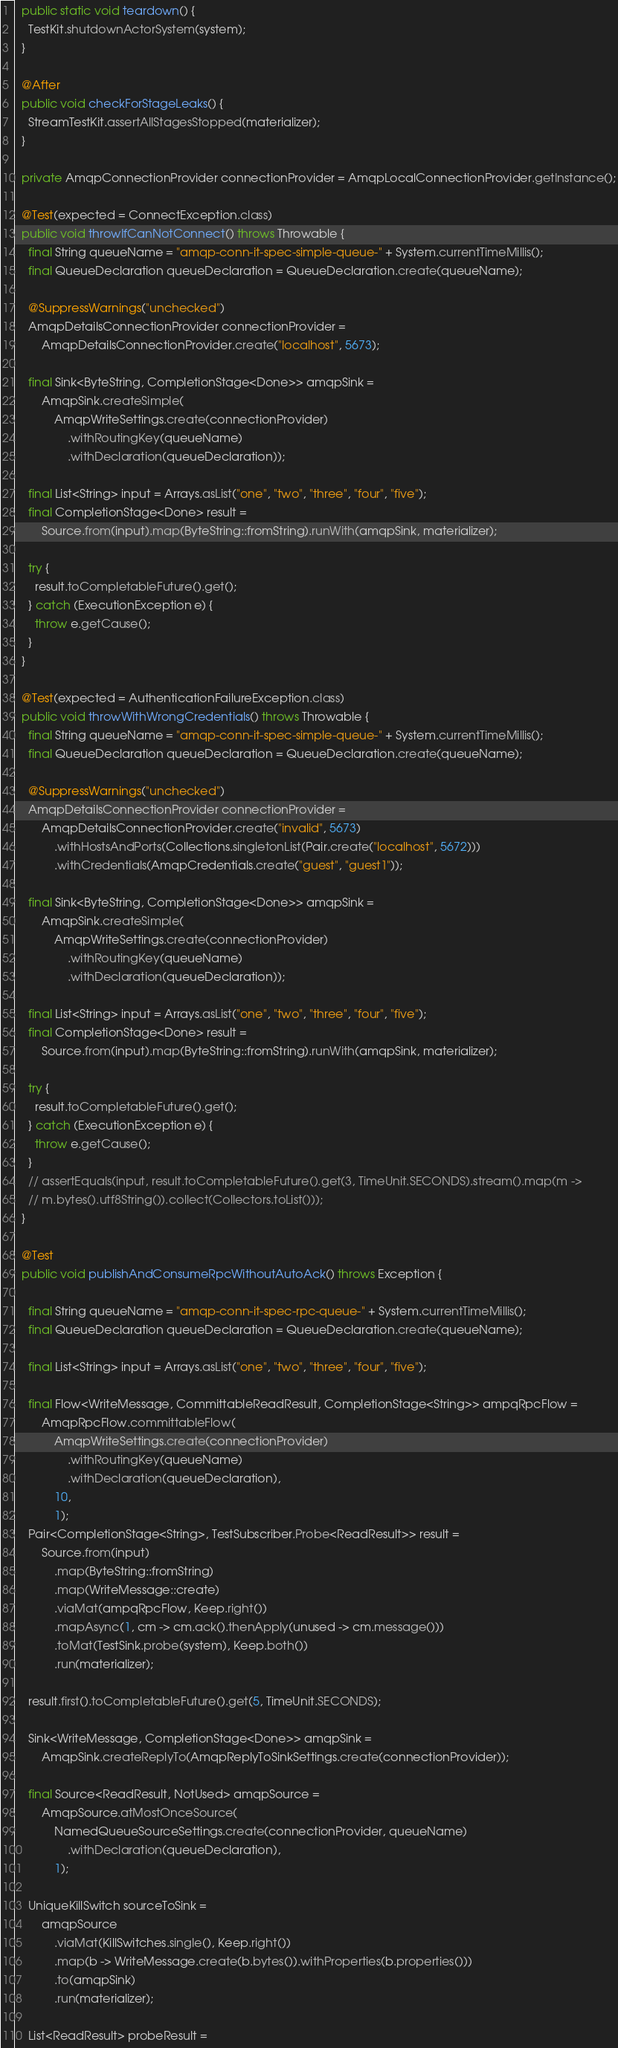Convert code to text. <code><loc_0><loc_0><loc_500><loc_500><_Java_>  public static void teardown() {
    TestKit.shutdownActorSystem(system);
  }

  @After
  public void checkForStageLeaks() {
    StreamTestKit.assertAllStagesStopped(materializer);
  }

  private AmqpConnectionProvider connectionProvider = AmqpLocalConnectionProvider.getInstance();

  @Test(expected = ConnectException.class)
  public void throwIfCanNotConnect() throws Throwable {
    final String queueName = "amqp-conn-it-spec-simple-queue-" + System.currentTimeMillis();
    final QueueDeclaration queueDeclaration = QueueDeclaration.create(queueName);

    @SuppressWarnings("unchecked")
    AmqpDetailsConnectionProvider connectionProvider =
        AmqpDetailsConnectionProvider.create("localhost", 5673);

    final Sink<ByteString, CompletionStage<Done>> amqpSink =
        AmqpSink.createSimple(
            AmqpWriteSettings.create(connectionProvider)
                .withRoutingKey(queueName)
                .withDeclaration(queueDeclaration));

    final List<String> input = Arrays.asList("one", "two", "three", "four", "five");
    final CompletionStage<Done> result =
        Source.from(input).map(ByteString::fromString).runWith(amqpSink, materializer);

    try {
      result.toCompletableFuture().get();
    } catch (ExecutionException e) {
      throw e.getCause();
    }
  }

  @Test(expected = AuthenticationFailureException.class)
  public void throwWithWrongCredentials() throws Throwable {
    final String queueName = "amqp-conn-it-spec-simple-queue-" + System.currentTimeMillis();
    final QueueDeclaration queueDeclaration = QueueDeclaration.create(queueName);

    @SuppressWarnings("unchecked")
    AmqpDetailsConnectionProvider connectionProvider =
        AmqpDetailsConnectionProvider.create("invalid", 5673)
            .withHostsAndPorts(Collections.singletonList(Pair.create("localhost", 5672)))
            .withCredentials(AmqpCredentials.create("guest", "guest1"));

    final Sink<ByteString, CompletionStage<Done>> amqpSink =
        AmqpSink.createSimple(
            AmqpWriteSettings.create(connectionProvider)
                .withRoutingKey(queueName)
                .withDeclaration(queueDeclaration));

    final List<String> input = Arrays.asList("one", "two", "three", "four", "five");
    final CompletionStage<Done> result =
        Source.from(input).map(ByteString::fromString).runWith(amqpSink, materializer);

    try {
      result.toCompletableFuture().get();
    } catch (ExecutionException e) {
      throw e.getCause();
    }
    // assertEquals(input, result.toCompletableFuture().get(3, TimeUnit.SECONDS).stream().map(m ->
    // m.bytes().utf8String()).collect(Collectors.toList()));
  }

  @Test
  public void publishAndConsumeRpcWithoutAutoAck() throws Exception {

    final String queueName = "amqp-conn-it-spec-rpc-queue-" + System.currentTimeMillis();
    final QueueDeclaration queueDeclaration = QueueDeclaration.create(queueName);

    final List<String> input = Arrays.asList("one", "two", "three", "four", "five");

    final Flow<WriteMessage, CommittableReadResult, CompletionStage<String>> ampqRpcFlow =
        AmqpRpcFlow.committableFlow(
            AmqpWriteSettings.create(connectionProvider)
                .withRoutingKey(queueName)
                .withDeclaration(queueDeclaration),
            10,
            1);
    Pair<CompletionStage<String>, TestSubscriber.Probe<ReadResult>> result =
        Source.from(input)
            .map(ByteString::fromString)
            .map(WriteMessage::create)
            .viaMat(ampqRpcFlow, Keep.right())
            .mapAsync(1, cm -> cm.ack().thenApply(unused -> cm.message()))
            .toMat(TestSink.probe(system), Keep.both())
            .run(materializer);

    result.first().toCompletableFuture().get(5, TimeUnit.SECONDS);

    Sink<WriteMessage, CompletionStage<Done>> amqpSink =
        AmqpSink.createReplyTo(AmqpReplyToSinkSettings.create(connectionProvider));

    final Source<ReadResult, NotUsed> amqpSource =
        AmqpSource.atMostOnceSource(
            NamedQueueSourceSettings.create(connectionProvider, queueName)
                .withDeclaration(queueDeclaration),
            1);

    UniqueKillSwitch sourceToSink =
        amqpSource
            .viaMat(KillSwitches.single(), Keep.right())
            .map(b -> WriteMessage.create(b.bytes()).withProperties(b.properties()))
            .to(amqpSink)
            .run(materializer);

    List<ReadResult> probeResult =</code> 